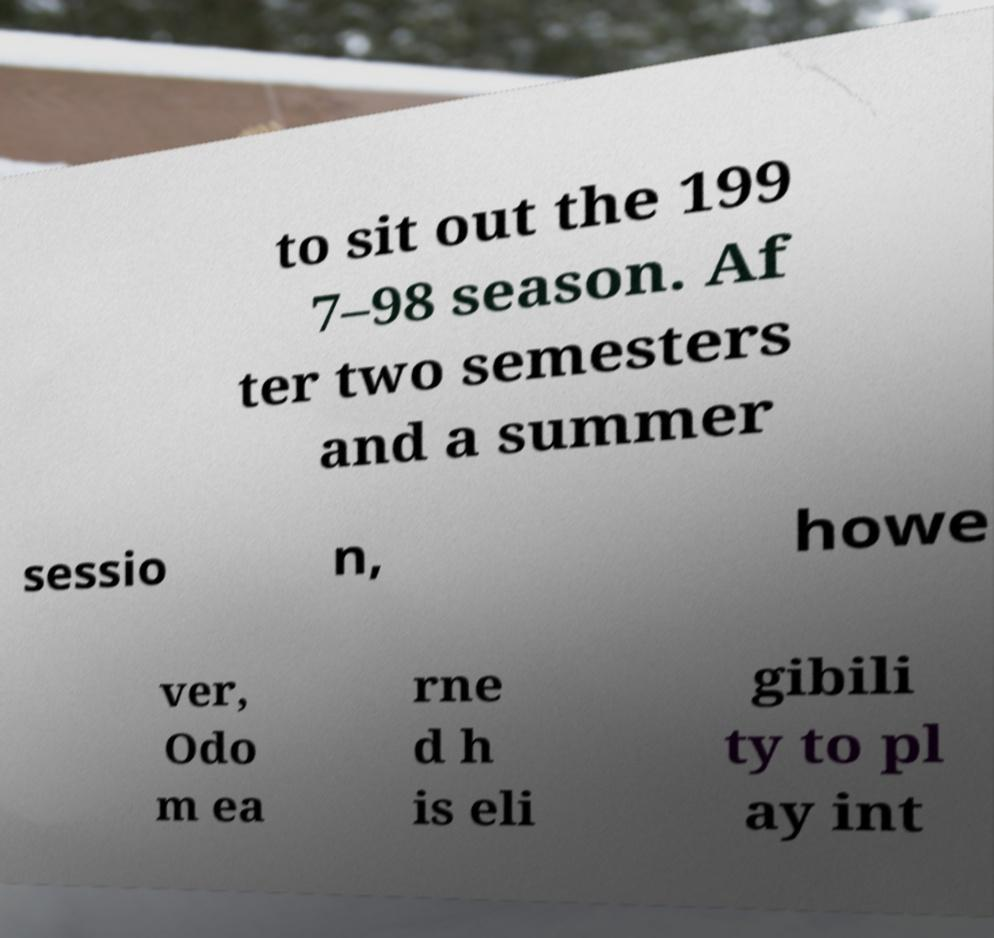Can you accurately transcribe the text from the provided image for me? to sit out the 199 7–98 season. Af ter two semesters and a summer sessio n, howe ver, Odo m ea rne d h is eli gibili ty to pl ay int 